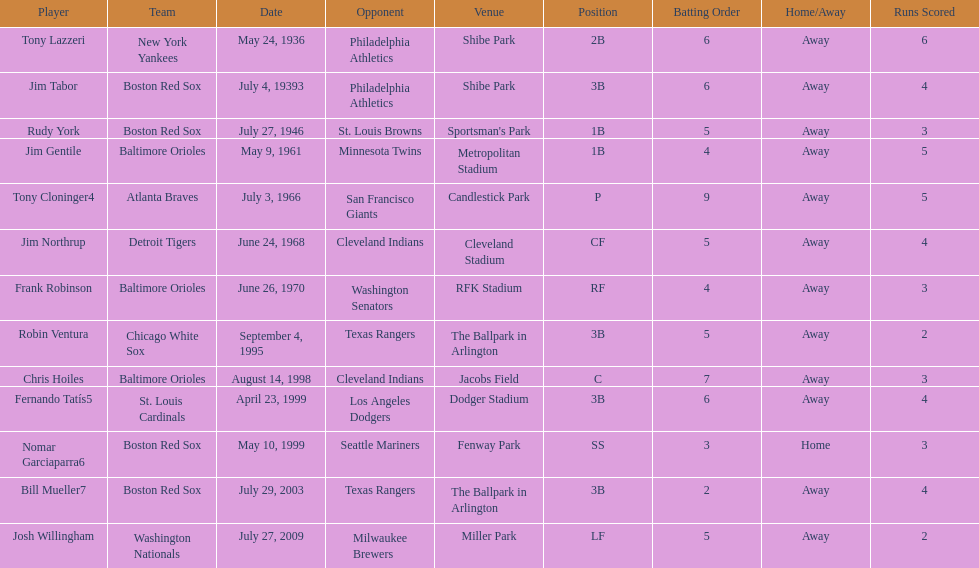Who were all of the players? Tony Lazzeri, Jim Tabor, Rudy York, Jim Gentile, Tony Cloninger4, Jim Northrup, Frank Robinson, Robin Ventura, Chris Hoiles, Fernando Tatís5, Nomar Garciaparra6, Bill Mueller7, Josh Willingham. What year was there a player for the yankees? May 24, 1936. What was the name of that 1936 yankees player? Tony Lazzeri. 